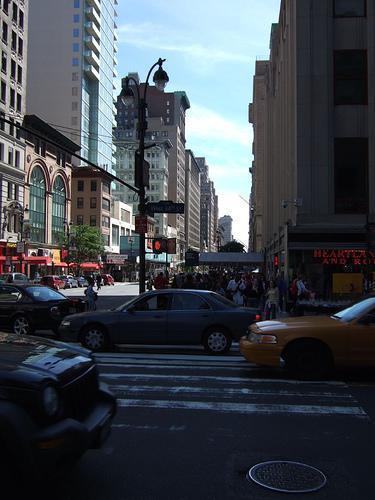How many cars are in the picture?
Give a very brief answer. 4. 